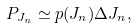Convert formula to latex. <formula><loc_0><loc_0><loc_500><loc_500>P _ { J _ { n } } \simeq p ( J _ { n } ) \Delta J _ { n } ,</formula> 